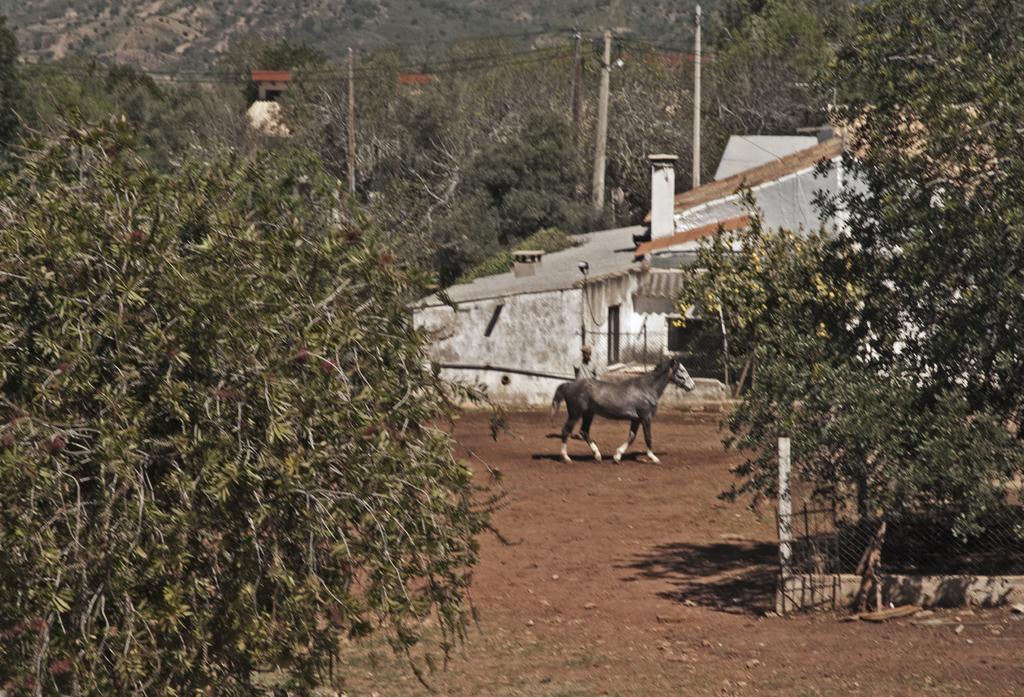Please provide a concise description of this image. In this image we can see an animal and a person standing on the ground. Here we can see trees, poles, wires, mesh, and houses. 